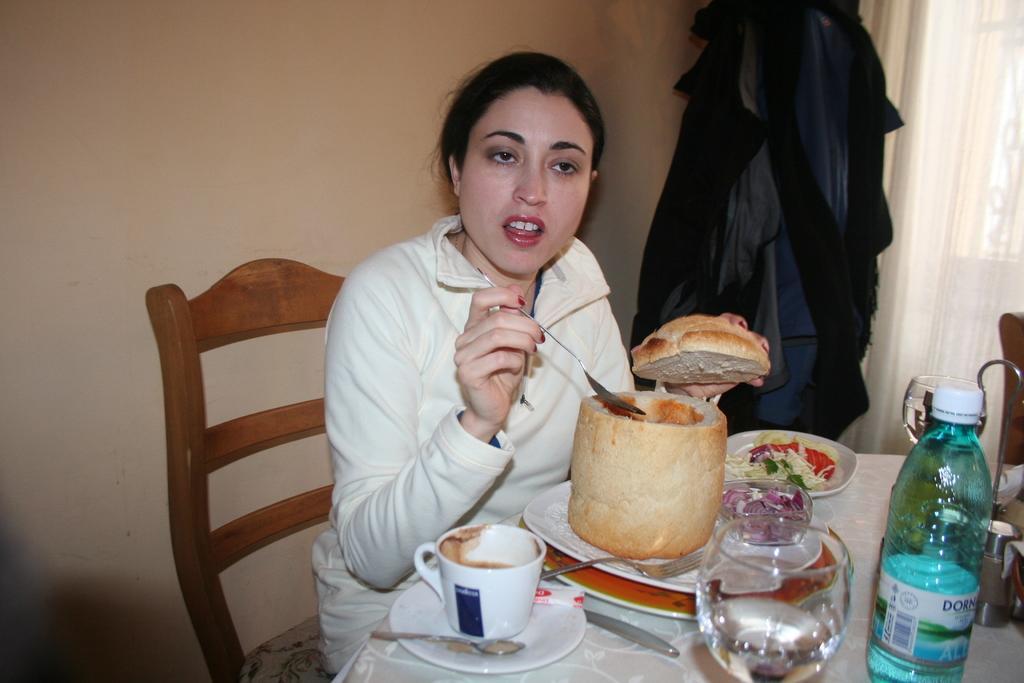Can you describe this image briefly? In the picture I can see a woman is sitting on a chair in front of table and holding a spoon and food item in hands. On the table I can see a cup, saucers, food item on a plate, glass, bottle and other objects. In the background I can see clothes, white color curtains and a wall. 